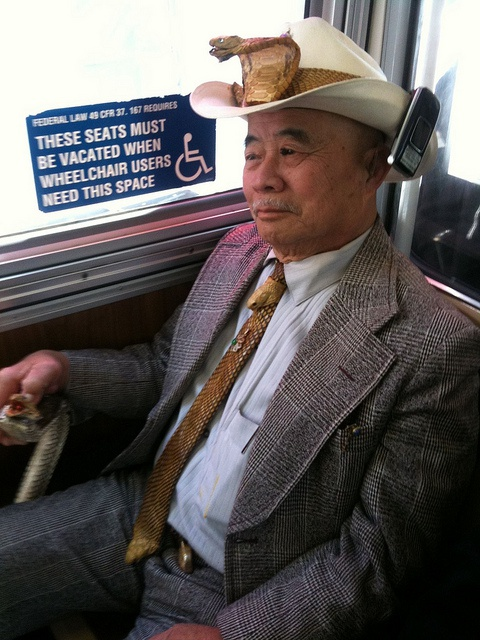Describe the objects in this image and their specific colors. I can see people in ivory, black, gray, maroon, and darkgray tones, tie in ivory, maroon, black, and gray tones, and cell phone in ivory, black, gray, darkgray, and purple tones in this image. 